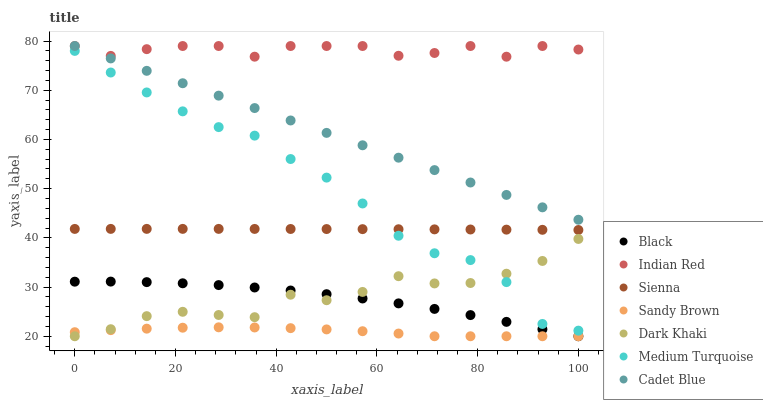Does Sandy Brown have the minimum area under the curve?
Answer yes or no. Yes. Does Indian Red have the maximum area under the curve?
Answer yes or no. Yes. Does Cadet Blue have the minimum area under the curve?
Answer yes or no. No. Does Cadet Blue have the maximum area under the curve?
Answer yes or no. No. Is Cadet Blue the smoothest?
Answer yes or no. Yes. Is Dark Khaki the roughest?
Answer yes or no. Yes. Is Indian Red the smoothest?
Answer yes or no. No. Is Indian Red the roughest?
Answer yes or no. No. Does Dark Khaki have the lowest value?
Answer yes or no. Yes. Does Cadet Blue have the lowest value?
Answer yes or no. No. Does Indian Red have the highest value?
Answer yes or no. Yes. Does Sienna have the highest value?
Answer yes or no. No. Is Sienna less than Cadet Blue?
Answer yes or no. Yes. Is Cadet Blue greater than Sandy Brown?
Answer yes or no. Yes. Does Black intersect Dark Khaki?
Answer yes or no. Yes. Is Black less than Dark Khaki?
Answer yes or no. No. Is Black greater than Dark Khaki?
Answer yes or no. No. Does Sienna intersect Cadet Blue?
Answer yes or no. No. 